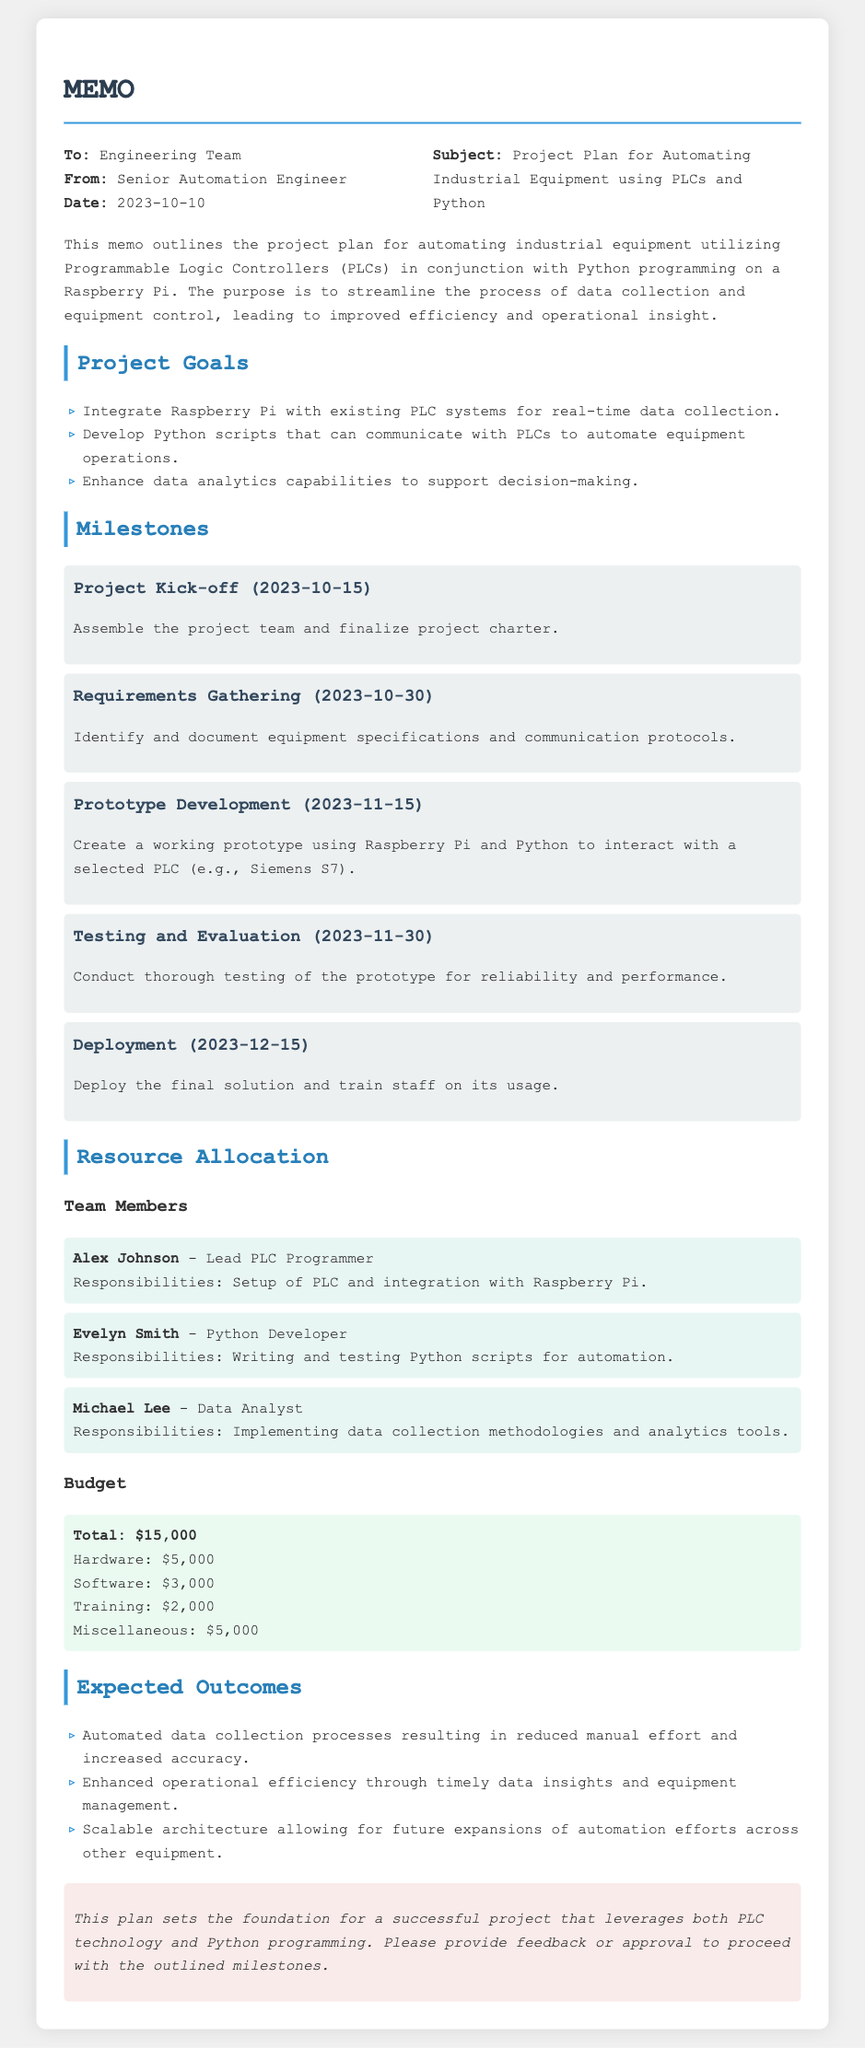What is the subject of the memo? The subject outlines the focus of the project, which is automating industrial equipment using specific technologies.
Answer: Project Plan for Automating Industrial Equipment using PLCs and Python Who is the author of the memo? The author's name indicates who has written the memo, which is relevant for accountability and follow-up.
Answer: Senior Automation Engineer What is the budget for hardware? The document provides specific allocations within the total budget, making it easy to identify the budget for each category.
Answer: $5,000 What is the completion date for the Prototype Development milestone? This date indicates when the team expects to have a working prototype, providing a timeline for progress.
Answer: 2023-11-15 What are the expected outcomes of the project? This summary provides insights into the goals of the project and what success would look like.
Answer: Automated data collection processes resulting in reduced manual effort and increased accuracy Who is responsible for writing and testing Python scripts? This question highlights the key personnel involved in the project, establishing roles and responsibilities.
Answer: Evelyn Smith What is the total budget for the project? The total budget represents the financial commitment necessary for project completion, indicating its scope.
Answer: $15,000 What is the date of the project kick-off? The starting date is crucial for planning and resource allocation throughout the project's duration.
Answer: 2023-10-15 What is the goal related to data analytics? Understanding specific goals related to data analytics helps assess the project's focus on decision-making capabilities.
Answer: Enhance data analytics capabilities to support decision-making 